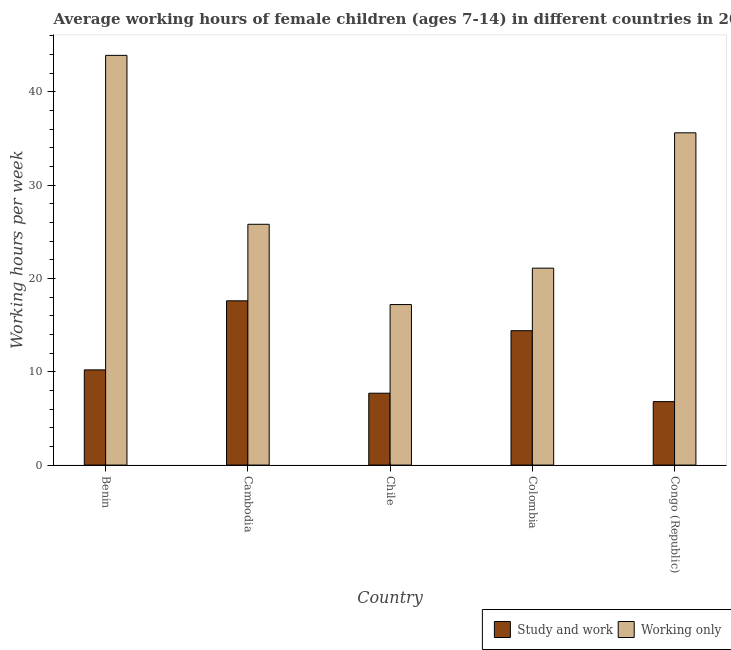How many different coloured bars are there?
Ensure brevity in your answer.  2. How many groups of bars are there?
Offer a terse response. 5. Are the number of bars per tick equal to the number of legend labels?
Ensure brevity in your answer.  Yes. Are the number of bars on each tick of the X-axis equal?
Give a very brief answer. Yes. How many bars are there on the 3rd tick from the right?
Make the answer very short. 2. What is the label of the 3rd group of bars from the left?
Give a very brief answer. Chile. What is the average working hour of children involved in study and work in Congo (Republic)?
Give a very brief answer. 6.8. Across all countries, what is the minimum average working hour of children involved in study and work?
Offer a terse response. 6.8. In which country was the average working hour of children involved in study and work maximum?
Make the answer very short. Cambodia. What is the total average working hour of children involved in only work in the graph?
Provide a short and direct response. 143.6. What is the difference between the average working hour of children involved in only work in Benin and that in Colombia?
Offer a terse response. 22.8. What is the difference between the average working hour of children involved in only work in Benin and the average working hour of children involved in study and work in Colombia?
Provide a succinct answer. 29.5. What is the average average working hour of children involved in only work per country?
Your answer should be compact. 28.72. What is the difference between the average working hour of children involved in study and work and average working hour of children involved in only work in Cambodia?
Your response must be concise. -8.2. In how many countries, is the average working hour of children involved in only work greater than 12 hours?
Provide a short and direct response. 5. What is the ratio of the average working hour of children involved in only work in Benin to that in Chile?
Your answer should be very brief. 2.55. Is the difference between the average working hour of children involved in only work in Chile and Congo (Republic) greater than the difference between the average working hour of children involved in study and work in Chile and Congo (Republic)?
Your answer should be very brief. No. What is the difference between the highest and the second highest average working hour of children involved in study and work?
Offer a terse response. 3.2. What does the 2nd bar from the left in Congo (Republic) represents?
Your response must be concise. Working only. What does the 1st bar from the right in Cambodia represents?
Give a very brief answer. Working only. Are all the bars in the graph horizontal?
Offer a terse response. No. How many countries are there in the graph?
Your response must be concise. 5. What is the difference between two consecutive major ticks on the Y-axis?
Provide a succinct answer. 10. Does the graph contain grids?
Your answer should be very brief. No. Where does the legend appear in the graph?
Provide a succinct answer. Bottom right. What is the title of the graph?
Keep it short and to the point. Average working hours of female children (ages 7-14) in different countries in 2012. What is the label or title of the X-axis?
Your answer should be compact. Country. What is the label or title of the Y-axis?
Your answer should be compact. Working hours per week. What is the Working hours per week of Study and work in Benin?
Your response must be concise. 10.2. What is the Working hours per week of Working only in Benin?
Offer a terse response. 43.9. What is the Working hours per week in Study and work in Cambodia?
Ensure brevity in your answer.  17.6. What is the Working hours per week in Working only in Cambodia?
Provide a succinct answer. 25.8. What is the Working hours per week of Study and work in Chile?
Your answer should be very brief. 7.7. What is the Working hours per week of Working only in Chile?
Your answer should be very brief. 17.2. What is the Working hours per week of Working only in Colombia?
Provide a short and direct response. 21.1. What is the Working hours per week of Working only in Congo (Republic)?
Your answer should be compact. 35.6. Across all countries, what is the maximum Working hours per week in Working only?
Your answer should be very brief. 43.9. What is the total Working hours per week in Study and work in the graph?
Your answer should be compact. 56.7. What is the total Working hours per week of Working only in the graph?
Your response must be concise. 143.6. What is the difference between the Working hours per week of Study and work in Benin and that in Cambodia?
Offer a terse response. -7.4. What is the difference between the Working hours per week of Working only in Benin and that in Cambodia?
Your response must be concise. 18.1. What is the difference between the Working hours per week of Working only in Benin and that in Chile?
Offer a very short reply. 26.7. What is the difference between the Working hours per week in Study and work in Benin and that in Colombia?
Give a very brief answer. -4.2. What is the difference between the Working hours per week of Working only in Benin and that in Colombia?
Provide a short and direct response. 22.8. What is the difference between the Working hours per week of Study and work in Benin and that in Congo (Republic)?
Your answer should be compact. 3.4. What is the difference between the Working hours per week in Study and work in Cambodia and that in Chile?
Your answer should be compact. 9.9. What is the difference between the Working hours per week of Working only in Cambodia and that in Chile?
Offer a very short reply. 8.6. What is the difference between the Working hours per week of Study and work in Cambodia and that in Colombia?
Ensure brevity in your answer.  3.2. What is the difference between the Working hours per week of Working only in Cambodia and that in Colombia?
Ensure brevity in your answer.  4.7. What is the difference between the Working hours per week in Study and work in Chile and that in Colombia?
Your answer should be compact. -6.7. What is the difference between the Working hours per week of Working only in Chile and that in Congo (Republic)?
Make the answer very short. -18.4. What is the difference between the Working hours per week in Study and work in Benin and the Working hours per week in Working only in Cambodia?
Keep it short and to the point. -15.6. What is the difference between the Working hours per week in Study and work in Benin and the Working hours per week in Working only in Colombia?
Your answer should be compact. -10.9. What is the difference between the Working hours per week of Study and work in Benin and the Working hours per week of Working only in Congo (Republic)?
Make the answer very short. -25.4. What is the difference between the Working hours per week in Study and work in Chile and the Working hours per week in Working only in Congo (Republic)?
Offer a very short reply. -27.9. What is the difference between the Working hours per week in Study and work in Colombia and the Working hours per week in Working only in Congo (Republic)?
Provide a short and direct response. -21.2. What is the average Working hours per week of Study and work per country?
Your answer should be very brief. 11.34. What is the average Working hours per week in Working only per country?
Provide a succinct answer. 28.72. What is the difference between the Working hours per week of Study and work and Working hours per week of Working only in Benin?
Your response must be concise. -33.7. What is the difference between the Working hours per week in Study and work and Working hours per week in Working only in Cambodia?
Ensure brevity in your answer.  -8.2. What is the difference between the Working hours per week of Study and work and Working hours per week of Working only in Congo (Republic)?
Keep it short and to the point. -28.8. What is the ratio of the Working hours per week of Study and work in Benin to that in Cambodia?
Offer a very short reply. 0.58. What is the ratio of the Working hours per week in Working only in Benin to that in Cambodia?
Your response must be concise. 1.7. What is the ratio of the Working hours per week in Study and work in Benin to that in Chile?
Ensure brevity in your answer.  1.32. What is the ratio of the Working hours per week of Working only in Benin to that in Chile?
Your answer should be compact. 2.55. What is the ratio of the Working hours per week in Study and work in Benin to that in Colombia?
Ensure brevity in your answer.  0.71. What is the ratio of the Working hours per week in Working only in Benin to that in Colombia?
Offer a terse response. 2.08. What is the ratio of the Working hours per week in Study and work in Benin to that in Congo (Republic)?
Offer a very short reply. 1.5. What is the ratio of the Working hours per week of Working only in Benin to that in Congo (Republic)?
Ensure brevity in your answer.  1.23. What is the ratio of the Working hours per week in Study and work in Cambodia to that in Chile?
Your answer should be compact. 2.29. What is the ratio of the Working hours per week in Study and work in Cambodia to that in Colombia?
Offer a very short reply. 1.22. What is the ratio of the Working hours per week of Working only in Cambodia to that in Colombia?
Offer a terse response. 1.22. What is the ratio of the Working hours per week of Study and work in Cambodia to that in Congo (Republic)?
Offer a terse response. 2.59. What is the ratio of the Working hours per week in Working only in Cambodia to that in Congo (Republic)?
Your answer should be compact. 0.72. What is the ratio of the Working hours per week in Study and work in Chile to that in Colombia?
Provide a short and direct response. 0.53. What is the ratio of the Working hours per week of Working only in Chile to that in Colombia?
Provide a succinct answer. 0.82. What is the ratio of the Working hours per week in Study and work in Chile to that in Congo (Republic)?
Your response must be concise. 1.13. What is the ratio of the Working hours per week in Working only in Chile to that in Congo (Republic)?
Your answer should be compact. 0.48. What is the ratio of the Working hours per week of Study and work in Colombia to that in Congo (Republic)?
Ensure brevity in your answer.  2.12. What is the ratio of the Working hours per week of Working only in Colombia to that in Congo (Republic)?
Ensure brevity in your answer.  0.59. What is the difference between the highest and the second highest Working hours per week in Study and work?
Your answer should be compact. 3.2. What is the difference between the highest and the second highest Working hours per week of Working only?
Give a very brief answer. 8.3. What is the difference between the highest and the lowest Working hours per week of Study and work?
Provide a short and direct response. 10.8. What is the difference between the highest and the lowest Working hours per week in Working only?
Provide a succinct answer. 26.7. 